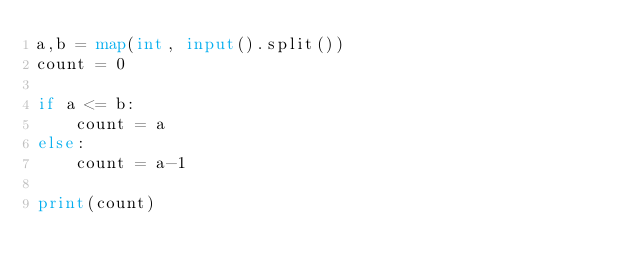Convert code to text. <code><loc_0><loc_0><loc_500><loc_500><_Python_>a,b = map(int, input().split())
count = 0

if a <= b:
    count = a
else:
    count = a-1

print(count)</code> 